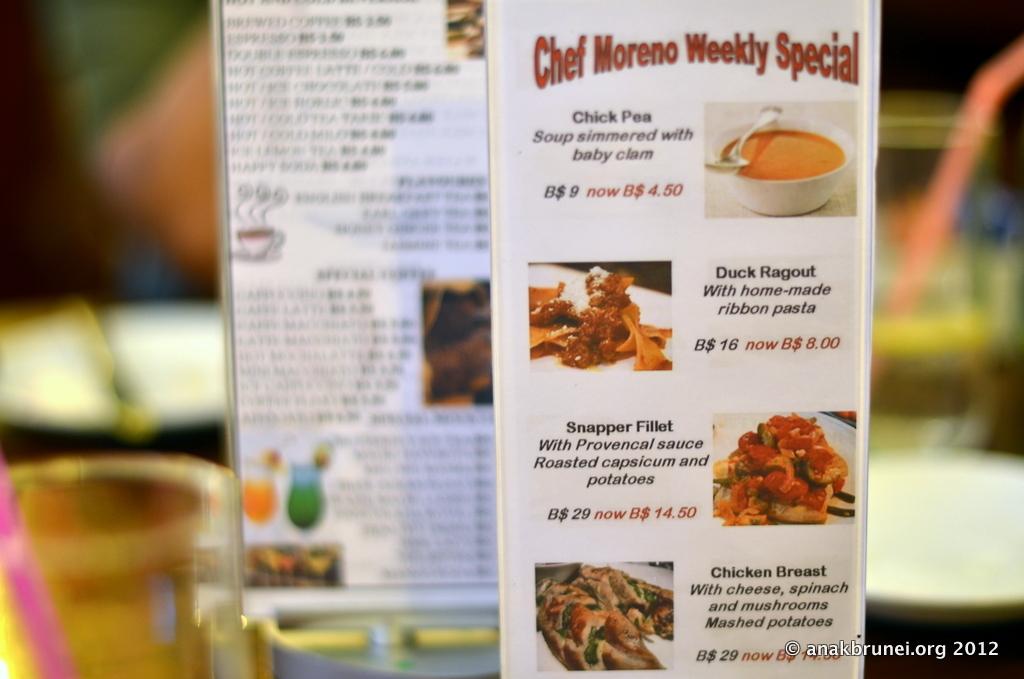What type of special is being advertised by this flyer?
Your answer should be very brief. Chef moreno weekly special. What year was this photo from?
Make the answer very short. 2012. 